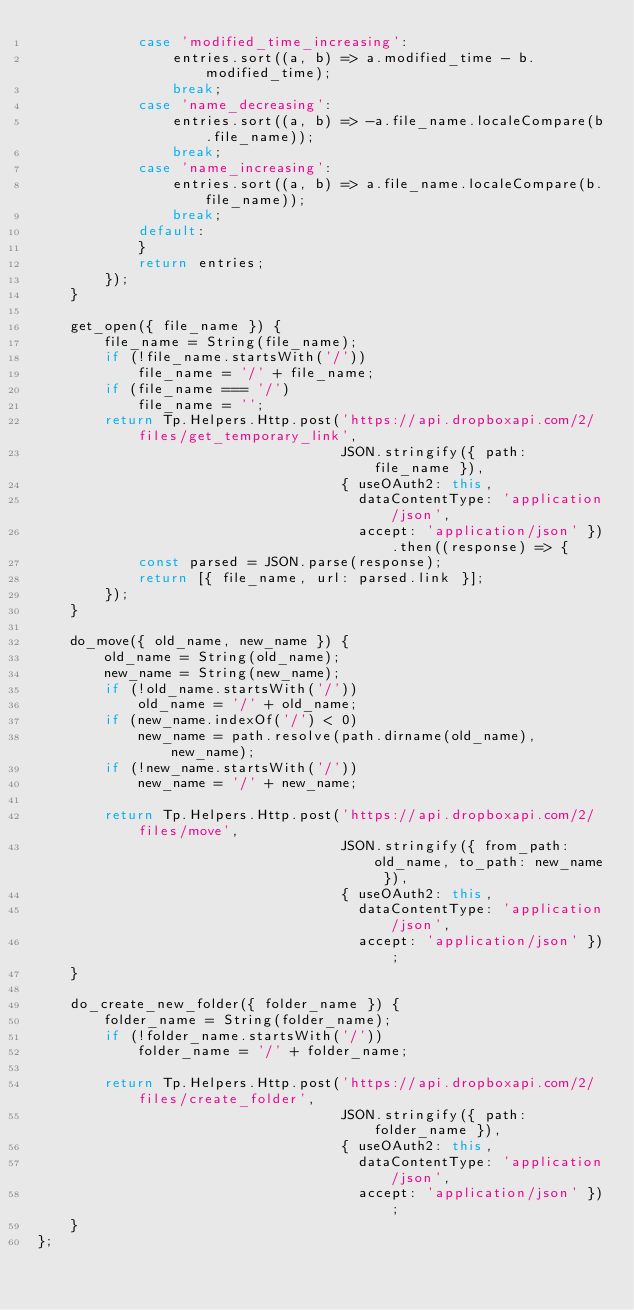<code> <loc_0><loc_0><loc_500><loc_500><_JavaScript_>            case 'modified_time_increasing':
                entries.sort((a, b) => a.modified_time - b.modified_time);
                break;
            case 'name_decreasing':
                entries.sort((a, b) => -a.file_name.localeCompare(b.file_name));
                break;
            case 'name_increasing':
                entries.sort((a, b) => a.file_name.localeCompare(b.file_name));
                break;
            default:
            }
            return entries;
        });
    }

    get_open({ file_name }) {
        file_name = String(file_name);
        if (!file_name.startsWith('/'))
            file_name = '/' + file_name;
        if (file_name === '/')
            file_name = '';
        return Tp.Helpers.Http.post('https://api.dropboxapi.com/2/files/get_temporary_link',
                                    JSON.stringify({ path: file_name }),
                                    { useOAuth2: this,
                                      dataContentType: 'application/json',
                                      accept: 'application/json' }).then((response) => {
            const parsed = JSON.parse(response);
            return [{ file_name, url: parsed.link }];
        });
    }

    do_move({ old_name, new_name }) {
        old_name = String(old_name);
        new_name = String(new_name);
        if (!old_name.startsWith('/'))
            old_name = '/' + old_name;
        if (new_name.indexOf('/') < 0)
            new_name = path.resolve(path.dirname(old_name), new_name);
        if (!new_name.startsWith('/'))
            new_name = '/' + new_name;

        return Tp.Helpers.Http.post('https://api.dropboxapi.com/2/files/move',
                                    JSON.stringify({ from_path: old_name, to_path: new_name }),
                                    { useOAuth2: this,
                                      dataContentType: 'application/json',
                                      accept: 'application/json' });
    }

    do_create_new_folder({ folder_name }) {
        folder_name = String(folder_name);
        if (!folder_name.startsWith('/'))
            folder_name = '/' + folder_name;

        return Tp.Helpers.Http.post('https://api.dropboxapi.com/2/files/create_folder',
                                    JSON.stringify({ path: folder_name }),
                                    { useOAuth2: this,
                                      dataContentType: 'application/json',
                                      accept: 'application/json' });
    }
};
</code> 